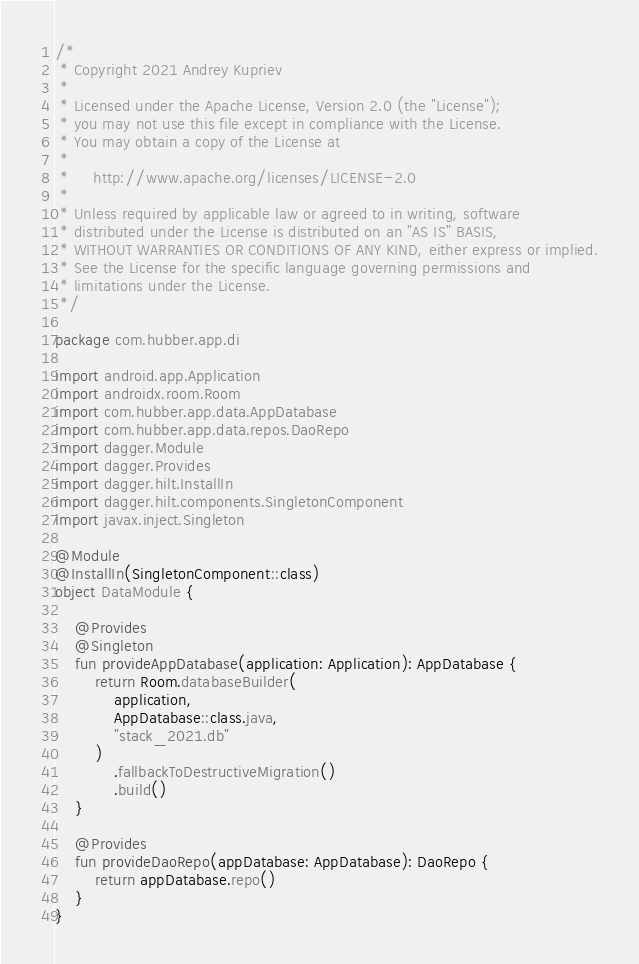Convert code to text. <code><loc_0><loc_0><loc_500><loc_500><_Kotlin_>/*
 * Copyright 2021 Andrey Kupriev
 *
 * Licensed under the Apache License, Version 2.0 (the "License");
 * you may not use this file except in compliance with the License.
 * You may obtain a copy of the License at
 *
 *     http://www.apache.org/licenses/LICENSE-2.0
 *
 * Unless required by applicable law or agreed to in writing, software
 * distributed under the License is distributed on an "AS IS" BASIS,
 * WITHOUT WARRANTIES OR CONDITIONS OF ANY KIND, either express or implied.
 * See the License for the specific language governing permissions and
 * limitations under the License.
 */
 
package com.hubber.app.di

import android.app.Application
import androidx.room.Room
import com.hubber.app.data.AppDatabase
import com.hubber.app.data.repos.DaoRepo
import dagger.Module
import dagger.Provides
import dagger.hilt.InstallIn
import dagger.hilt.components.SingletonComponent
import javax.inject.Singleton

@Module
@InstallIn(SingletonComponent::class)
object DataModule {

    @Provides
    @Singleton
    fun provideAppDatabase(application: Application): AppDatabase {
        return Room.databaseBuilder(
            application,
            AppDatabase::class.java,
            "stack_2021.db"
        )
            .fallbackToDestructiveMigration()
            .build()
    }

    @Provides
    fun provideDaoRepo(appDatabase: AppDatabase): DaoRepo {
        return appDatabase.repo()
    }
}
</code> 